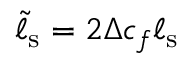<formula> <loc_0><loc_0><loc_500><loc_500>\tilde { \ell } _ { s } = 2 \Delta c _ { f } \ell _ { s }</formula> 